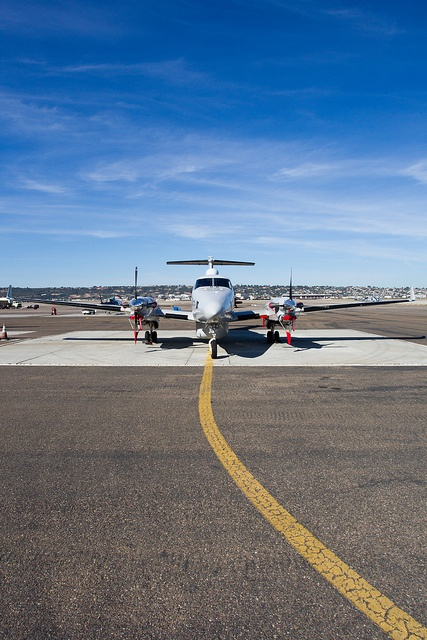Describe the objects in this image and their specific colors. I can see airplane in blue, black, lightgray, gray, and darkgray tones and airplane in blue, black, white, and gray tones in this image. 